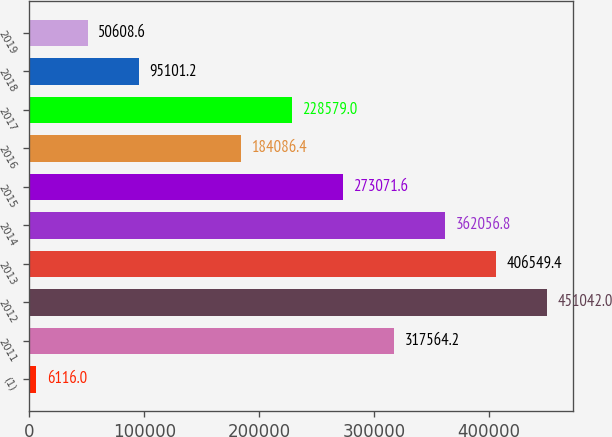Convert chart. <chart><loc_0><loc_0><loc_500><loc_500><bar_chart><fcel>(1)<fcel>2011<fcel>2012<fcel>2013<fcel>2014<fcel>2015<fcel>2016<fcel>2017<fcel>2018<fcel>2019<nl><fcel>6116<fcel>317564<fcel>451042<fcel>406549<fcel>362057<fcel>273072<fcel>184086<fcel>228579<fcel>95101.2<fcel>50608.6<nl></chart> 